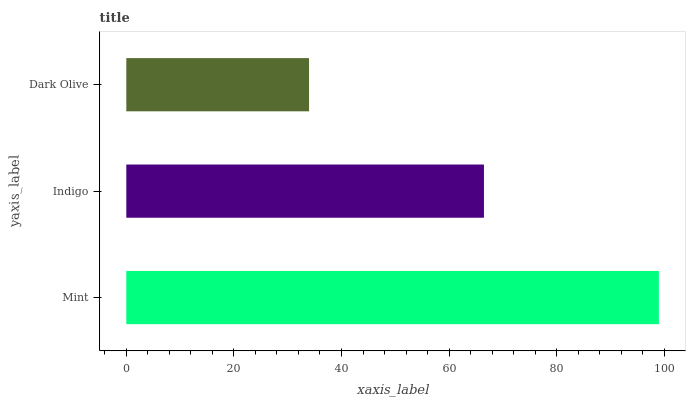Is Dark Olive the minimum?
Answer yes or no. Yes. Is Mint the maximum?
Answer yes or no. Yes. Is Indigo the minimum?
Answer yes or no. No. Is Indigo the maximum?
Answer yes or no. No. Is Mint greater than Indigo?
Answer yes or no. Yes. Is Indigo less than Mint?
Answer yes or no. Yes. Is Indigo greater than Mint?
Answer yes or no. No. Is Mint less than Indigo?
Answer yes or no. No. Is Indigo the high median?
Answer yes or no. Yes. Is Indigo the low median?
Answer yes or no. Yes. Is Dark Olive the high median?
Answer yes or no. No. Is Dark Olive the low median?
Answer yes or no. No. 